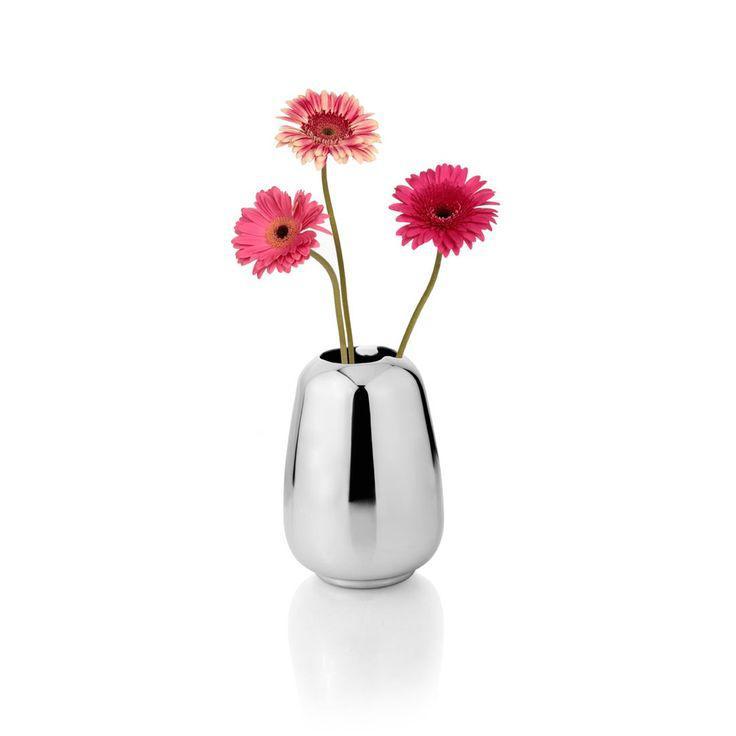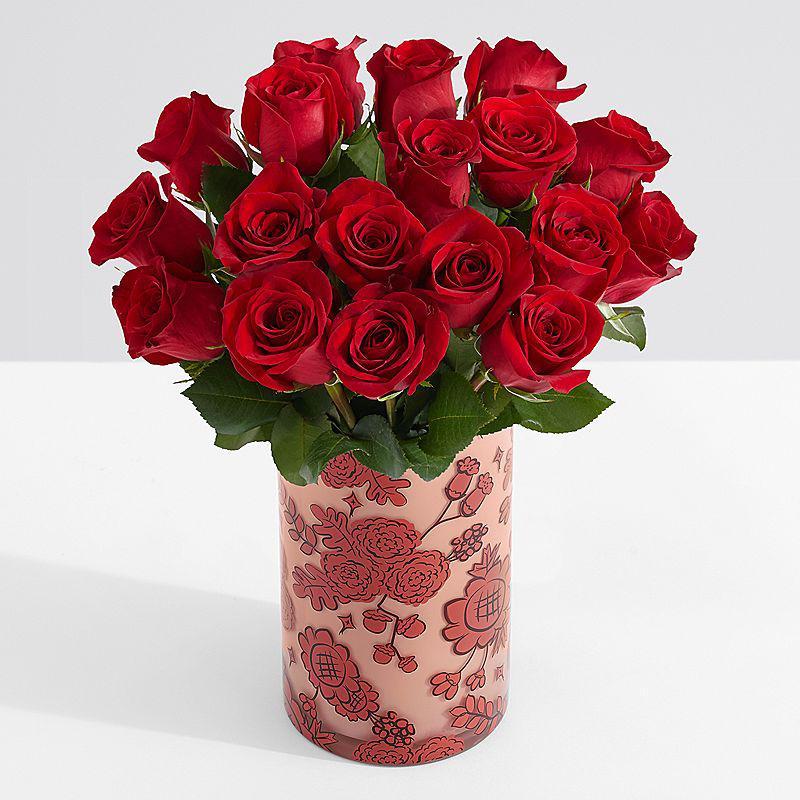The first image is the image on the left, the second image is the image on the right. For the images shown, is this caption "there are roses in a clear glass vase that is the same width on the bottom as it is on the top" true? Answer yes or no. No. The first image is the image on the left, the second image is the image on the right. Considering the images on both sides, is "There are three flowers in a small vase." valid? Answer yes or no. Yes. 